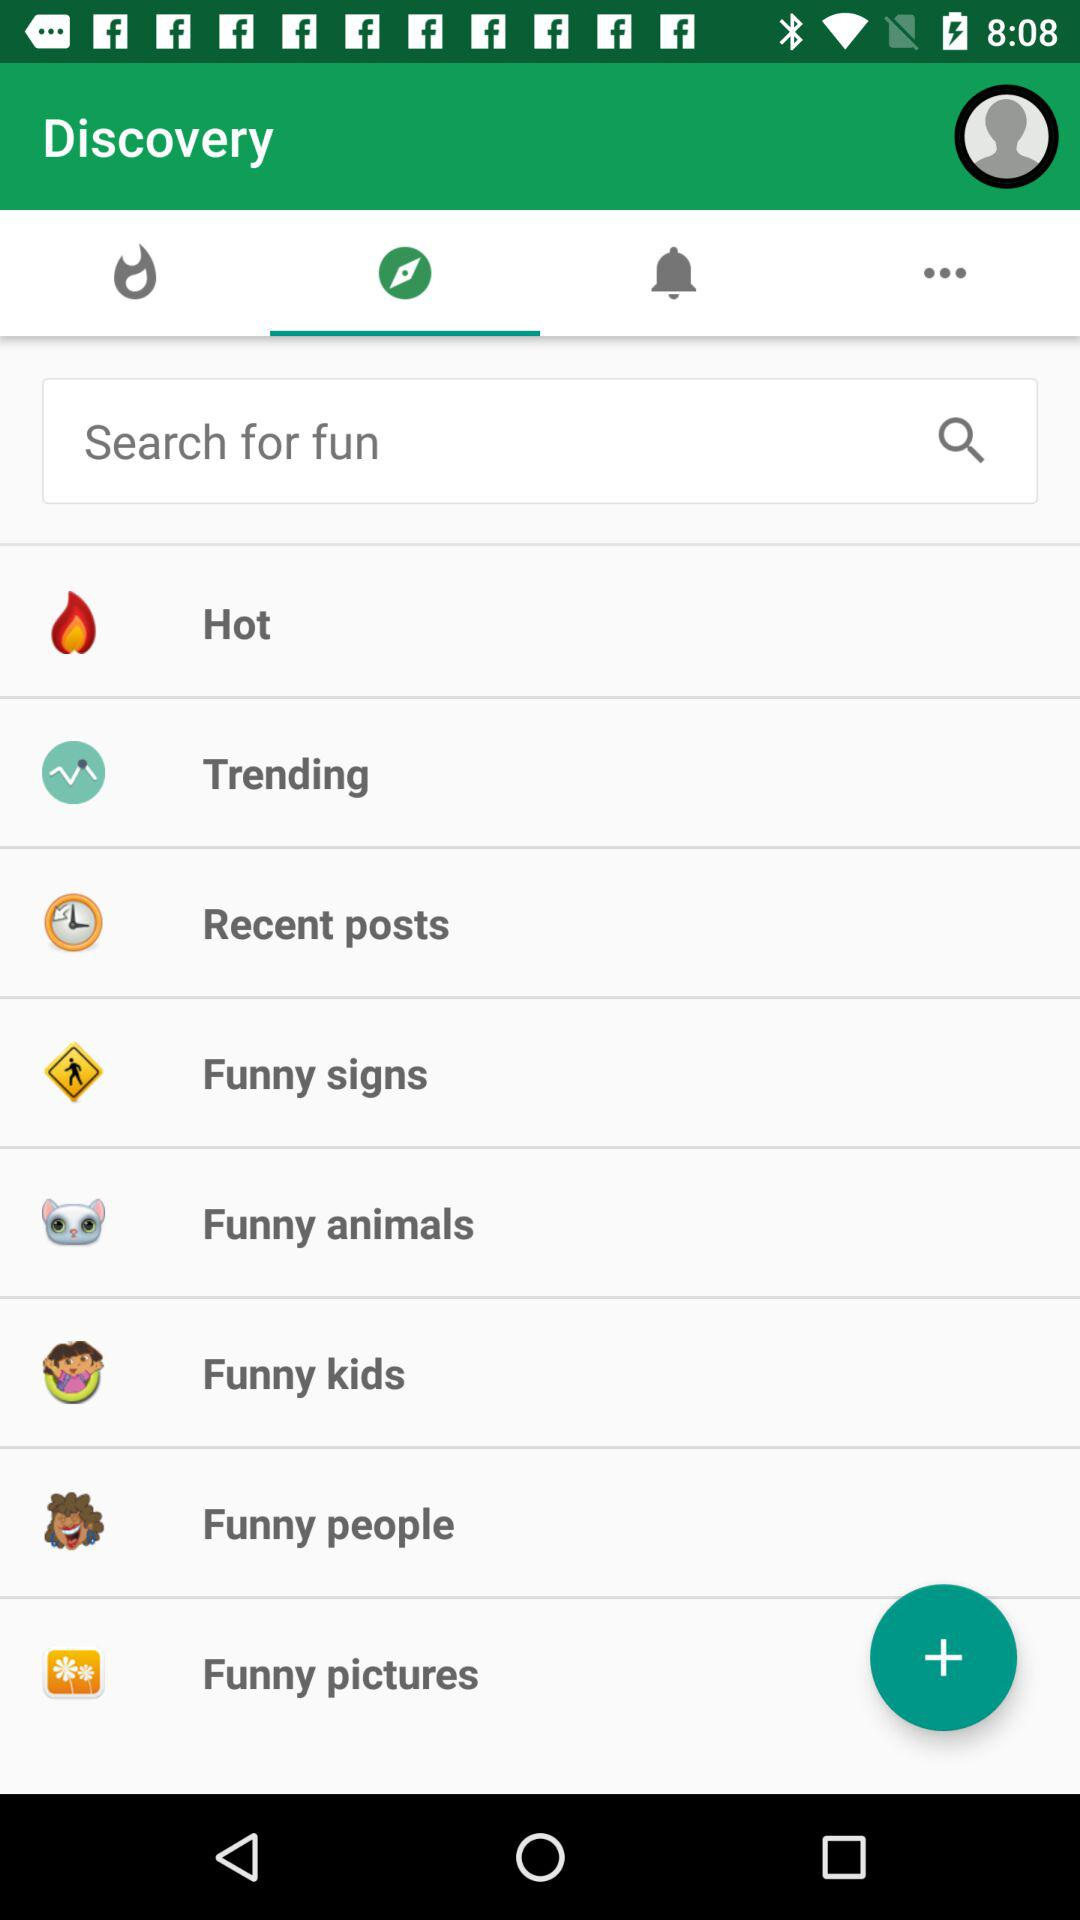Which tab is selected? The selected tab is "Compass". 